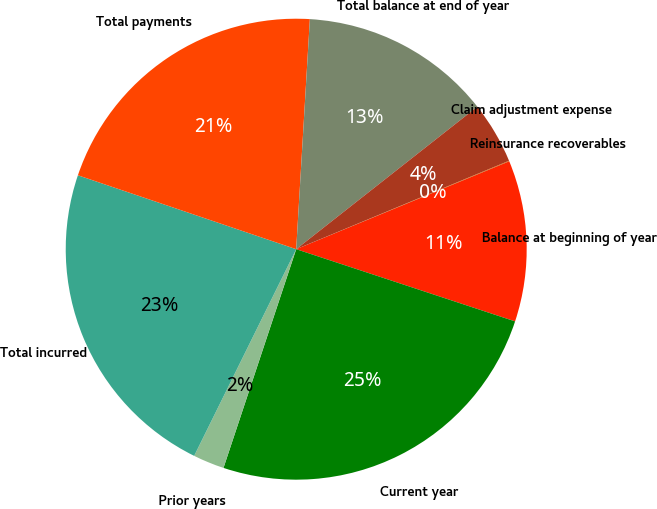<chart> <loc_0><loc_0><loc_500><loc_500><pie_chart><fcel>Balance at beginning of year<fcel>Current year<fcel>Prior years<fcel>Total incurred<fcel>Total payments<fcel>Total balance at end of year<fcel>Claim adjustment expense<fcel>Reinsurance recoverables<nl><fcel>11.3%<fcel>25.04%<fcel>2.19%<fcel>22.9%<fcel>20.75%<fcel>13.45%<fcel>4.34%<fcel>0.04%<nl></chart> 